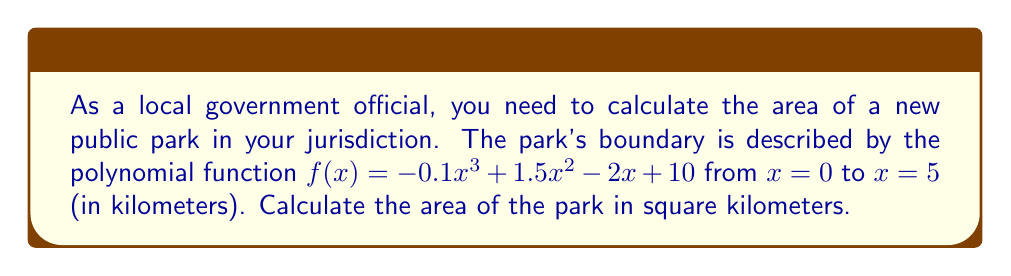Solve this math problem. To calculate the area bounded by a polynomial function and the x-axis, we need to use definite integration. Here's how we solve this problem step-by-step:

1) The area is given by the integral of $f(x)$ from $x = 0$ to $x = 5$:

   $$A = \int_0^5 f(x) dx = \int_0^5 (-0.1x^3 + 1.5x^2 - 2x + 10) dx$$

2) Integrate each term:
   $$A = [-0.025x^4 + 0.5x^3 - x^2 + 10x]_0^5$$

3) Evaluate the function at the upper and lower bounds:
   At $x = 5$: 
   $$-0.025(5^4) + 0.5(5^3) - (5^2) + 10(5) = -15.625 + 62.5 - 25 + 50 = 71.875$$
   
   At $x = 0$:
   $$-0.025(0^4) + 0.5(0^3) - (0^2) + 10(0) = 0$$

4) Subtract the lower bound from the upper bound:
   $$A = 71.875 - 0 = 71.875$$

Thus, the area of the park is 71.875 square kilometers.
Answer: 71.875 km² 